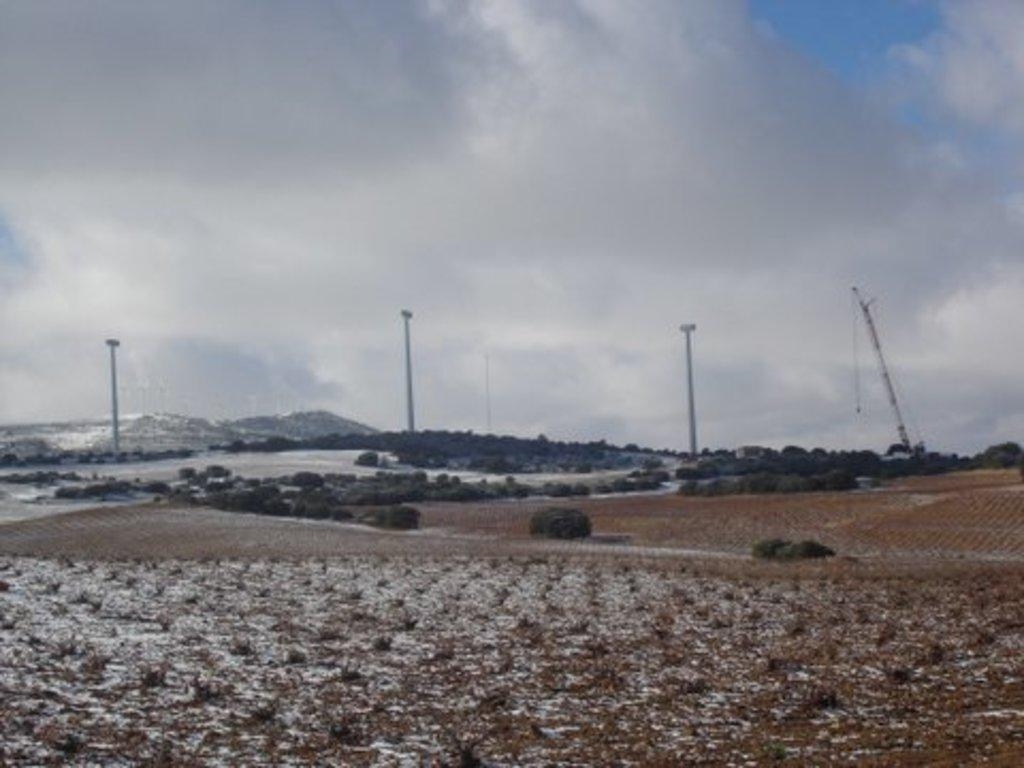What type of vegetation can be seen in the image? There are plants and trees in the image. What can be seen on the left side of the image? There are hills on the left side of the image. What is visible in the sky in the image? The sky is visible in the image, and clouds are present. What type of muscle is being exercised by the father in the image? There is no father or muscle present in the image; it features plants, trees, hills, and a sky with clouds. 